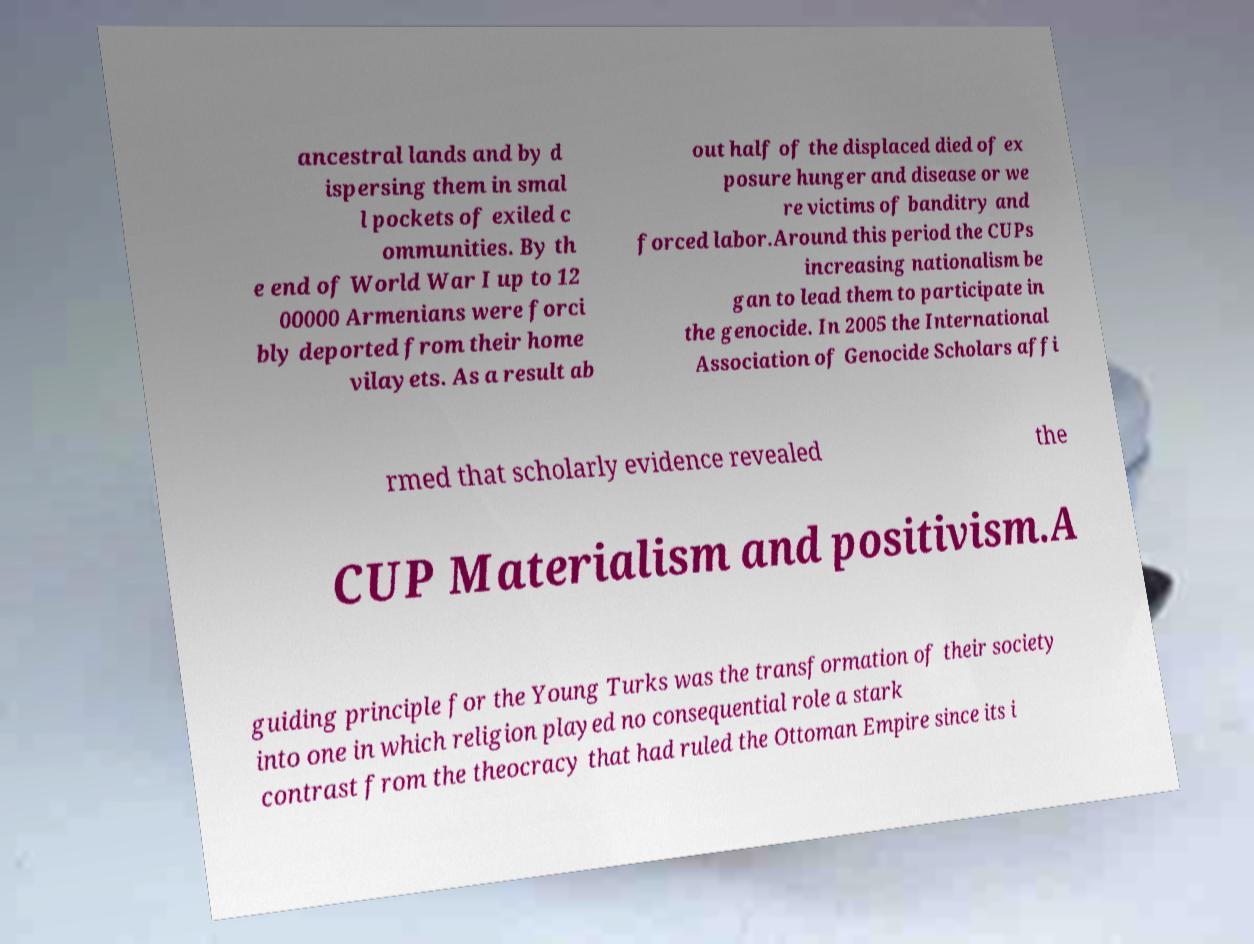What messages or text are displayed in this image? I need them in a readable, typed format. ancestral lands and by d ispersing them in smal l pockets of exiled c ommunities. By th e end of World War I up to 12 00000 Armenians were forci bly deported from their home vilayets. As a result ab out half of the displaced died of ex posure hunger and disease or we re victims of banditry and forced labor.Around this period the CUPs increasing nationalism be gan to lead them to participate in the genocide. In 2005 the International Association of Genocide Scholars affi rmed that scholarly evidence revealed the CUP Materialism and positivism.A guiding principle for the Young Turks was the transformation of their society into one in which religion played no consequential role a stark contrast from the theocracy that had ruled the Ottoman Empire since its i 